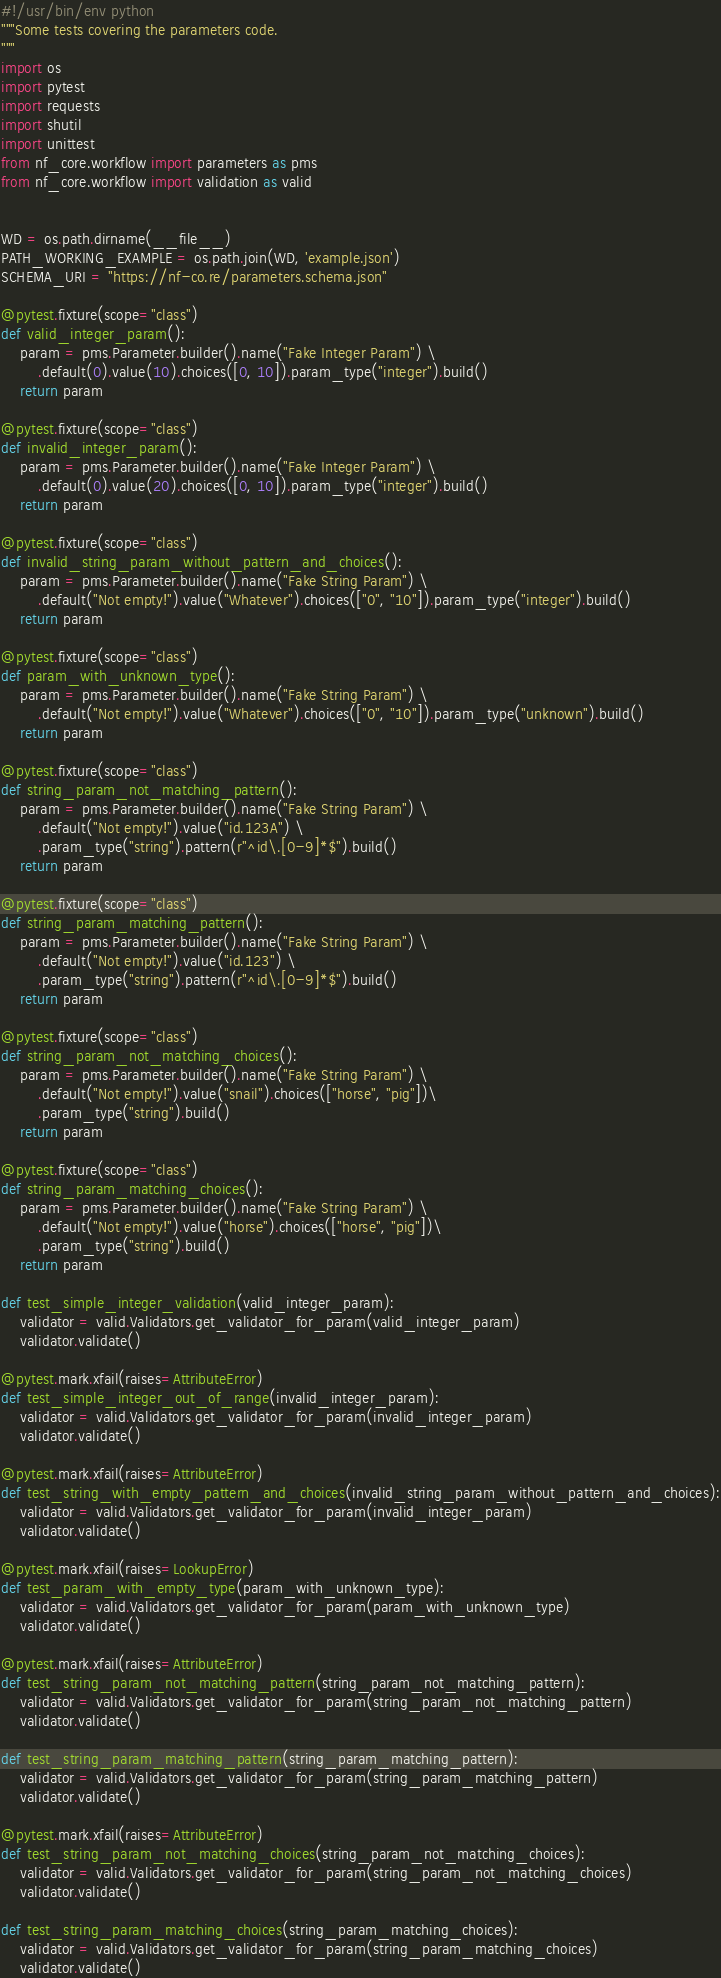Convert code to text. <code><loc_0><loc_0><loc_500><loc_500><_Python_>#!/usr/bin/env python
"""Some tests covering the parameters code.
"""
import os
import pytest
import requests
import shutil
import unittest
from nf_core.workflow import parameters as pms
from nf_core.workflow import validation as valid


WD = os.path.dirname(__file__)
PATH_WORKING_EXAMPLE = os.path.join(WD, 'example.json')
SCHEMA_URI = "https://nf-co.re/parameters.schema.json"

@pytest.fixture(scope="class")
def valid_integer_param():
    param = pms.Parameter.builder().name("Fake Integer Param") \
        .default(0).value(10).choices([0, 10]).param_type("integer").build()
    return param

@pytest.fixture(scope="class")
def invalid_integer_param():
    param = pms.Parameter.builder().name("Fake Integer Param") \
        .default(0).value(20).choices([0, 10]).param_type("integer").build()
    return param

@pytest.fixture(scope="class")
def invalid_string_param_without_pattern_and_choices():
    param = pms.Parameter.builder().name("Fake String Param") \
        .default("Not empty!").value("Whatever").choices(["0", "10"]).param_type("integer").build()
    return param

@pytest.fixture(scope="class")
def param_with_unknown_type():
    param = pms.Parameter.builder().name("Fake String Param") \
        .default("Not empty!").value("Whatever").choices(["0", "10"]).param_type("unknown").build()
    return param

@pytest.fixture(scope="class")
def string_param_not_matching_pattern():
    param = pms.Parameter.builder().name("Fake String Param") \
        .default("Not empty!").value("id.123A") \
        .param_type("string").pattern(r"^id\.[0-9]*$").build()
    return param

@pytest.fixture(scope="class")
def string_param_matching_pattern():
    param = pms.Parameter.builder().name("Fake String Param") \
        .default("Not empty!").value("id.123") \
        .param_type("string").pattern(r"^id\.[0-9]*$").build()
    return param

@pytest.fixture(scope="class")
def string_param_not_matching_choices():
    param = pms.Parameter.builder().name("Fake String Param") \
        .default("Not empty!").value("snail").choices(["horse", "pig"])\
        .param_type("string").build()
    return param

@pytest.fixture(scope="class")
def string_param_matching_choices():
    param = pms.Parameter.builder().name("Fake String Param") \
        .default("Not empty!").value("horse").choices(["horse", "pig"])\
        .param_type("string").build()
    return param

def test_simple_integer_validation(valid_integer_param):
    validator = valid.Validators.get_validator_for_param(valid_integer_param)
    validator.validate()

@pytest.mark.xfail(raises=AttributeError)
def test_simple_integer_out_of_range(invalid_integer_param):
    validator = valid.Validators.get_validator_for_param(invalid_integer_param)
    validator.validate()

@pytest.mark.xfail(raises=AttributeError)
def test_string_with_empty_pattern_and_choices(invalid_string_param_without_pattern_and_choices):
    validator = valid.Validators.get_validator_for_param(invalid_integer_param)
    validator.validate()

@pytest.mark.xfail(raises=LookupError)
def test_param_with_empty_type(param_with_unknown_type):
    validator = valid.Validators.get_validator_for_param(param_with_unknown_type)
    validator.validate()

@pytest.mark.xfail(raises=AttributeError)
def test_string_param_not_matching_pattern(string_param_not_matching_pattern):
    validator = valid.Validators.get_validator_for_param(string_param_not_matching_pattern)
    validator.validate()

def test_string_param_matching_pattern(string_param_matching_pattern):
    validator = valid.Validators.get_validator_for_param(string_param_matching_pattern)
    validator.validate()

@pytest.mark.xfail(raises=AttributeError)
def test_string_param_not_matching_choices(string_param_not_matching_choices):
    validator = valid.Validators.get_validator_for_param(string_param_not_matching_choices)
    validator.validate()

def test_string_param_matching_choices(string_param_matching_choices):
    validator = valid.Validators.get_validator_for_param(string_param_matching_choices)
    validator.validate()</code> 